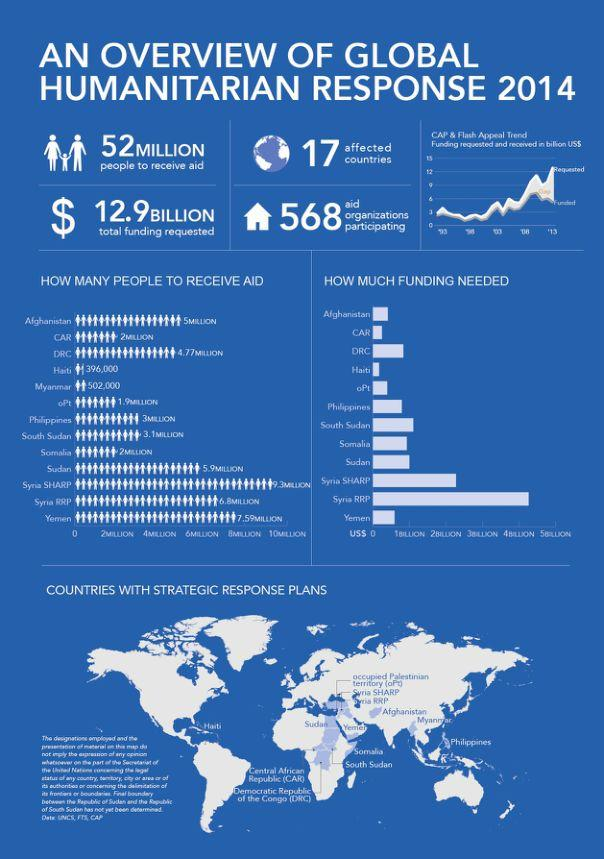Give some essential details in this illustration. In 2014, 568 aid organizations participated in the Global Humanitarian Response. According to the Global Humanitarian Response 2014, approximately 2 million people in Somalia will receive aid. According to the Global Humanitarian Response 2014, 502,000 people in Myanmar will receive aid. 